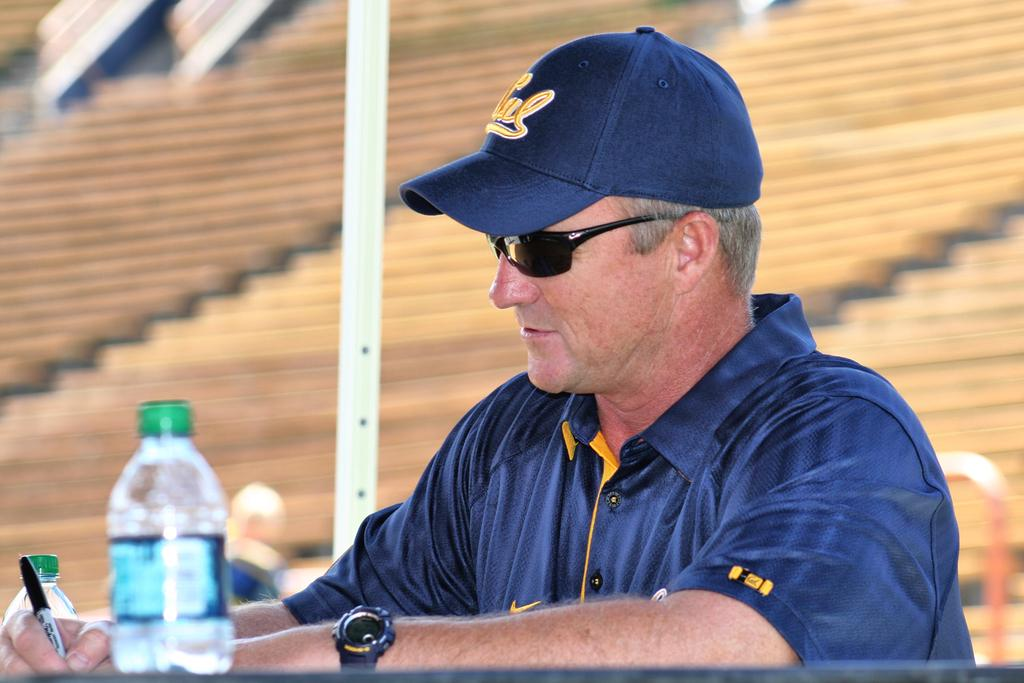What is the main subject of the image? There is a person in the image. What is the person wearing on their upper body? The person is wearing a blue color tee shirt. What headgear is the person wearing? The person is wearing a hat. What type of eyewear is the person wearing? The person is wearing shades. What object is the person holding? The person is holding a pen. Where is the person sitting in the image? The person is sitting in front of a desk. What can be seen on the desk in the image? The desk has a bottle on it. What type of fireman equipment can be seen in the image? There is no fireman equipment present in the image. What room is the person in, based on the image? The image does not provide enough information to determine the specific room the person is in. 